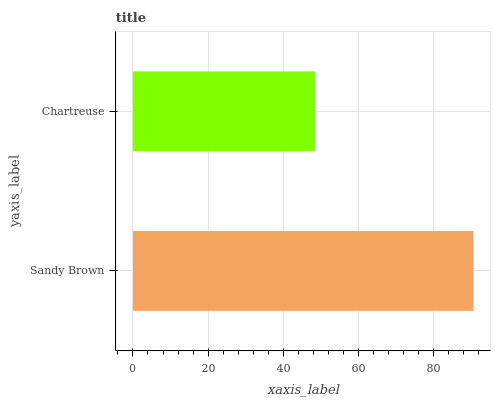Is Chartreuse the minimum?
Answer yes or no. Yes. Is Sandy Brown the maximum?
Answer yes or no. Yes. Is Chartreuse the maximum?
Answer yes or no. No. Is Sandy Brown greater than Chartreuse?
Answer yes or no. Yes. Is Chartreuse less than Sandy Brown?
Answer yes or no. Yes. Is Chartreuse greater than Sandy Brown?
Answer yes or no. No. Is Sandy Brown less than Chartreuse?
Answer yes or no. No. Is Sandy Brown the high median?
Answer yes or no. Yes. Is Chartreuse the low median?
Answer yes or no. Yes. Is Chartreuse the high median?
Answer yes or no. No. Is Sandy Brown the low median?
Answer yes or no. No. 